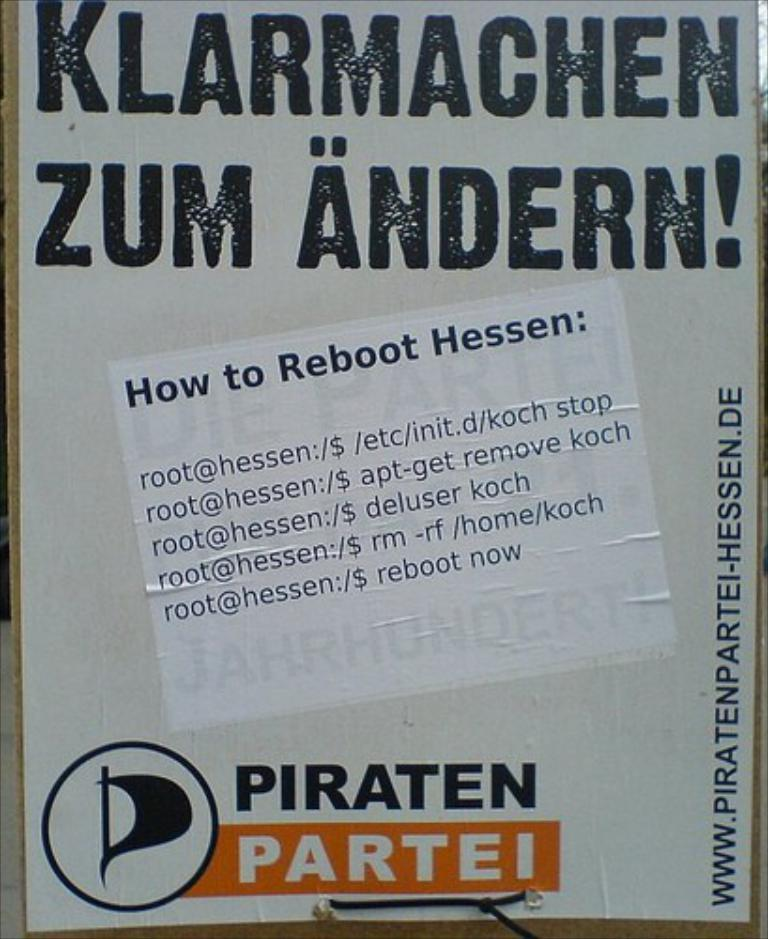What is the main subject of the image? There is a poster in the image. What type of instrument is being played by the person wearing a stocking in the image? There is no person wearing a stocking or playing an instrument present in the image, as the only fact provided is about a poster. 